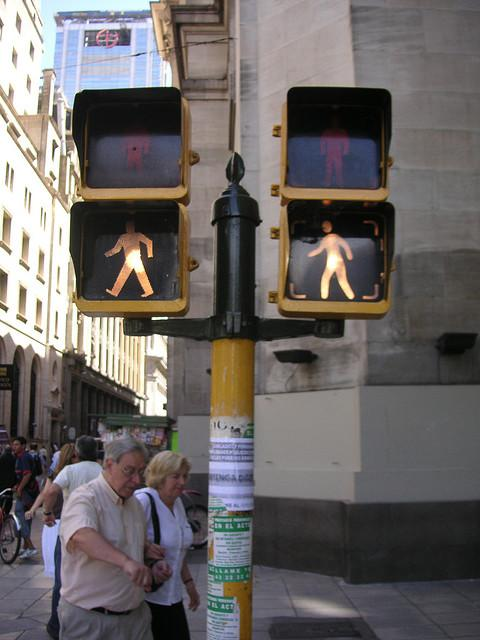What is the traffic light permitting? crossing 